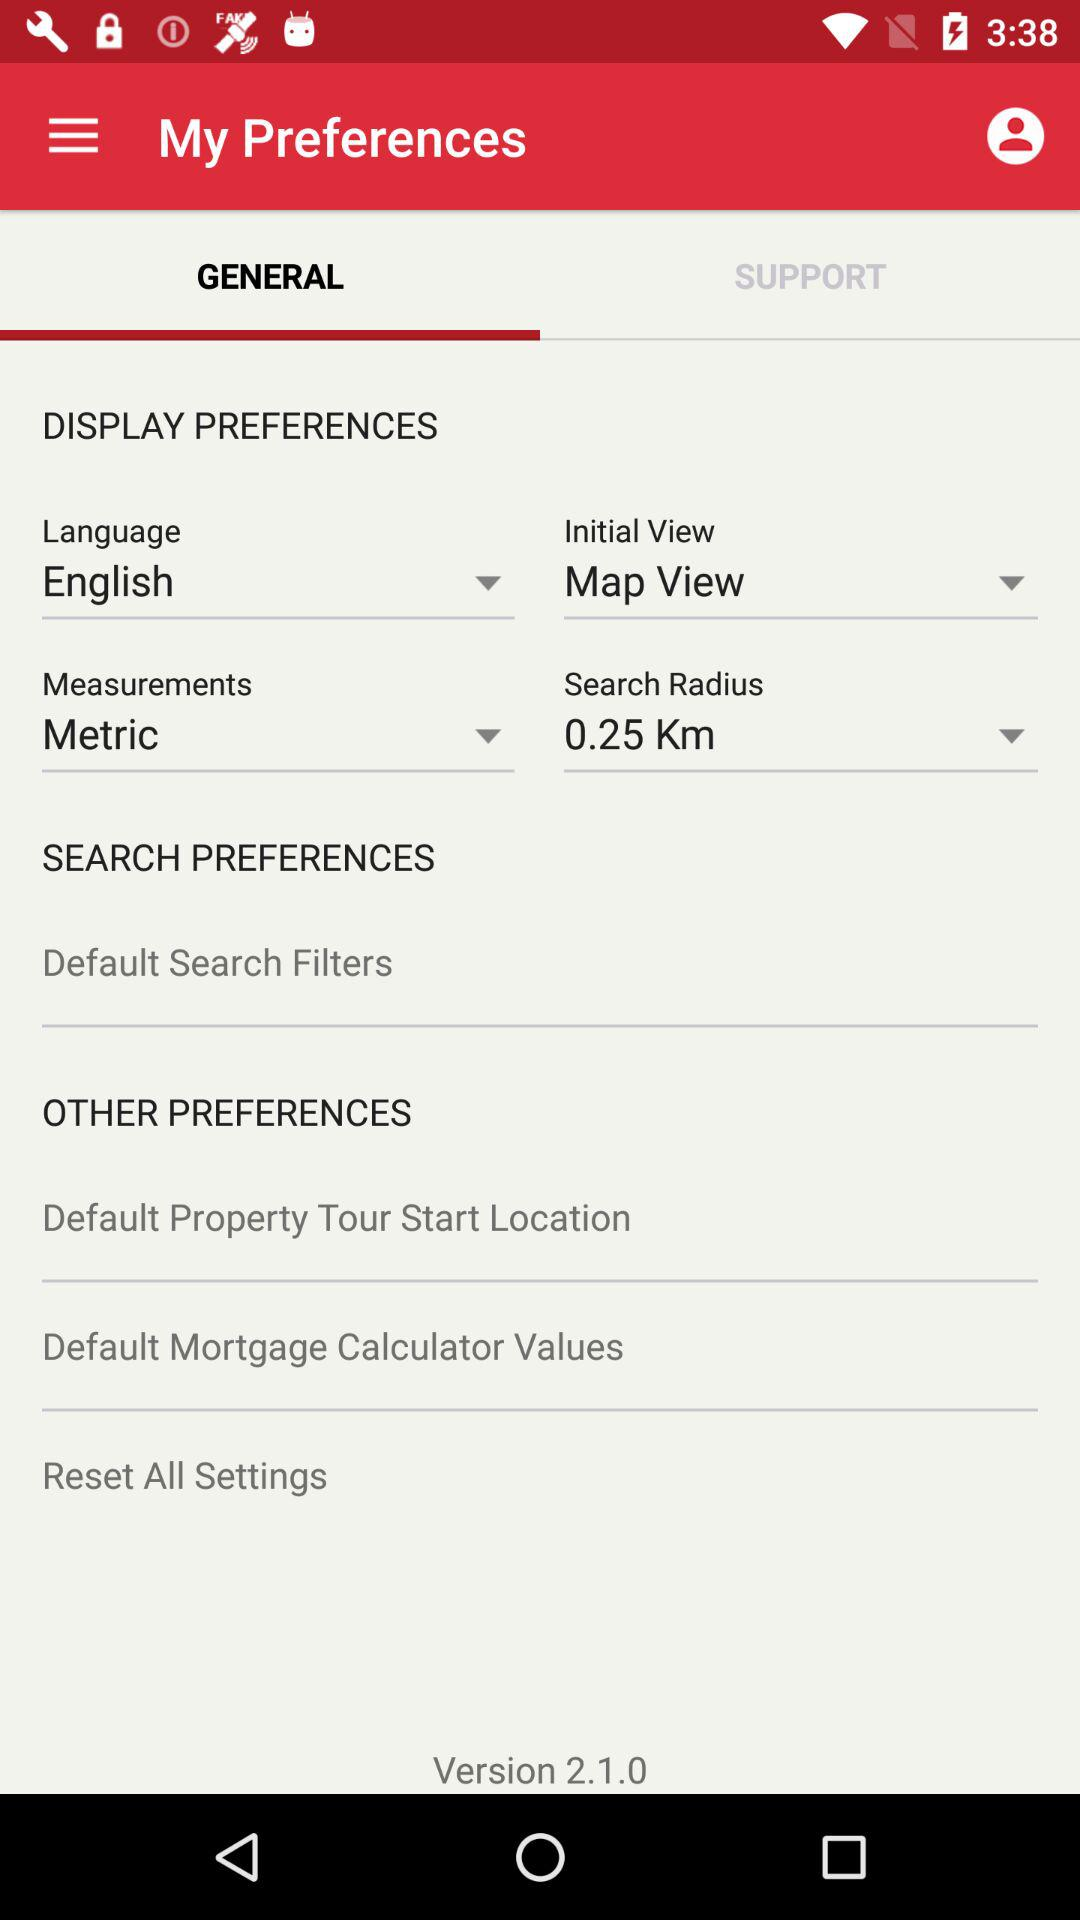What is the application name?
When the provided information is insufficient, respond with <no answer>. <no answer> 